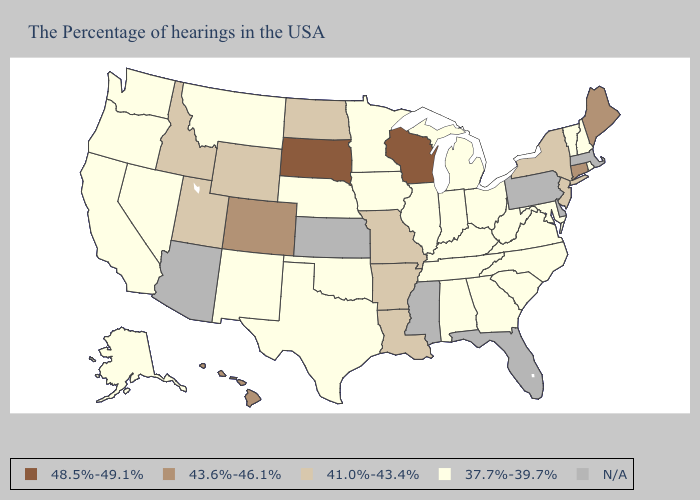Does Missouri have the highest value in the USA?
Keep it brief. No. What is the lowest value in the Northeast?
Quick response, please. 37.7%-39.7%. Name the states that have a value in the range 37.7%-39.7%?
Short answer required. Rhode Island, New Hampshire, Vermont, Maryland, Virginia, North Carolina, South Carolina, West Virginia, Ohio, Georgia, Michigan, Kentucky, Indiana, Alabama, Tennessee, Illinois, Minnesota, Iowa, Nebraska, Oklahoma, Texas, New Mexico, Montana, Nevada, California, Washington, Oregon, Alaska. Name the states that have a value in the range 43.6%-46.1%?
Answer briefly. Maine, Connecticut, Colorado, Hawaii. Among the states that border Minnesota , which have the highest value?
Quick response, please. Wisconsin, South Dakota. Which states have the lowest value in the MidWest?
Keep it brief. Ohio, Michigan, Indiana, Illinois, Minnesota, Iowa, Nebraska. Does Minnesota have the lowest value in the USA?
Quick response, please. Yes. Which states have the lowest value in the MidWest?
Give a very brief answer. Ohio, Michigan, Indiana, Illinois, Minnesota, Iowa, Nebraska. What is the value of Vermont?
Keep it brief. 37.7%-39.7%. Which states hav the highest value in the South?
Concise answer only. Louisiana, Arkansas. Does Iowa have the lowest value in the USA?
Short answer required. Yes. What is the highest value in the South ?
Short answer required. 41.0%-43.4%. What is the highest value in states that border Ohio?
Give a very brief answer. 37.7%-39.7%. Does Vermont have the highest value in the Northeast?
Quick response, please. No. 